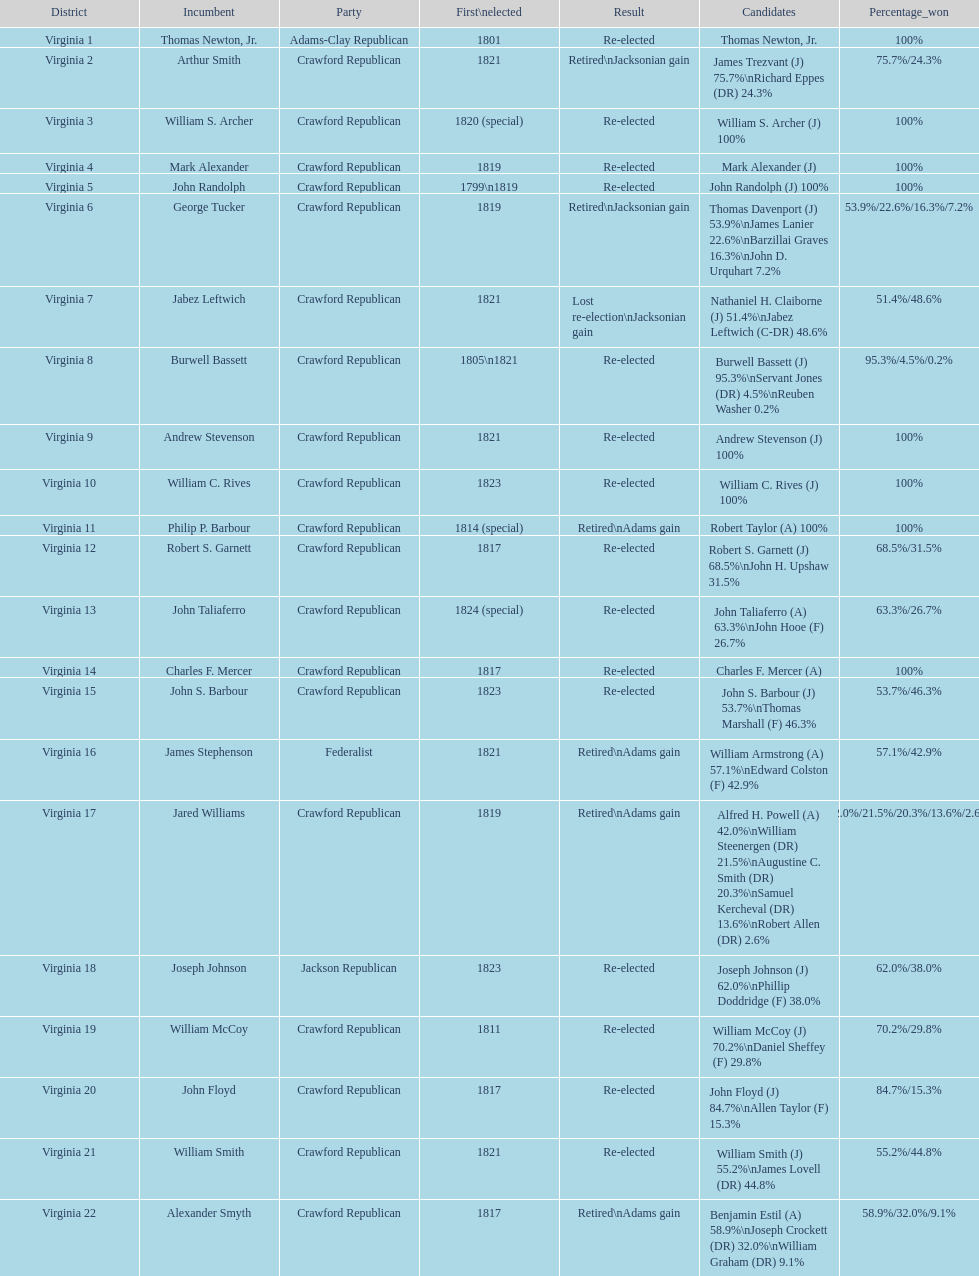What is the last party on this chart? Crawford Republican. 